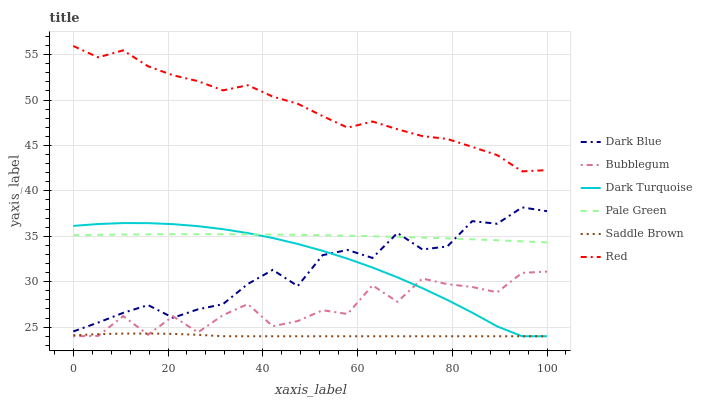Does Saddle Brown have the minimum area under the curve?
Answer yes or no. Yes. Does Red have the maximum area under the curve?
Answer yes or no. Yes. Does Bubblegum have the minimum area under the curve?
Answer yes or no. No. Does Bubblegum have the maximum area under the curve?
Answer yes or no. No. Is Pale Green the smoothest?
Answer yes or no. Yes. Is Bubblegum the roughest?
Answer yes or no. Yes. Is Dark Blue the smoothest?
Answer yes or no. No. Is Dark Blue the roughest?
Answer yes or no. No. Does Dark Turquoise have the lowest value?
Answer yes or no. Yes. Does Dark Blue have the lowest value?
Answer yes or no. No. Does Red have the highest value?
Answer yes or no. Yes. Does Bubblegum have the highest value?
Answer yes or no. No. Is Dark Turquoise less than Red?
Answer yes or no. Yes. Is Pale Green greater than Bubblegum?
Answer yes or no. Yes. Does Dark Turquoise intersect Bubblegum?
Answer yes or no. Yes. Is Dark Turquoise less than Bubblegum?
Answer yes or no. No. Is Dark Turquoise greater than Bubblegum?
Answer yes or no. No. Does Dark Turquoise intersect Red?
Answer yes or no. No. 